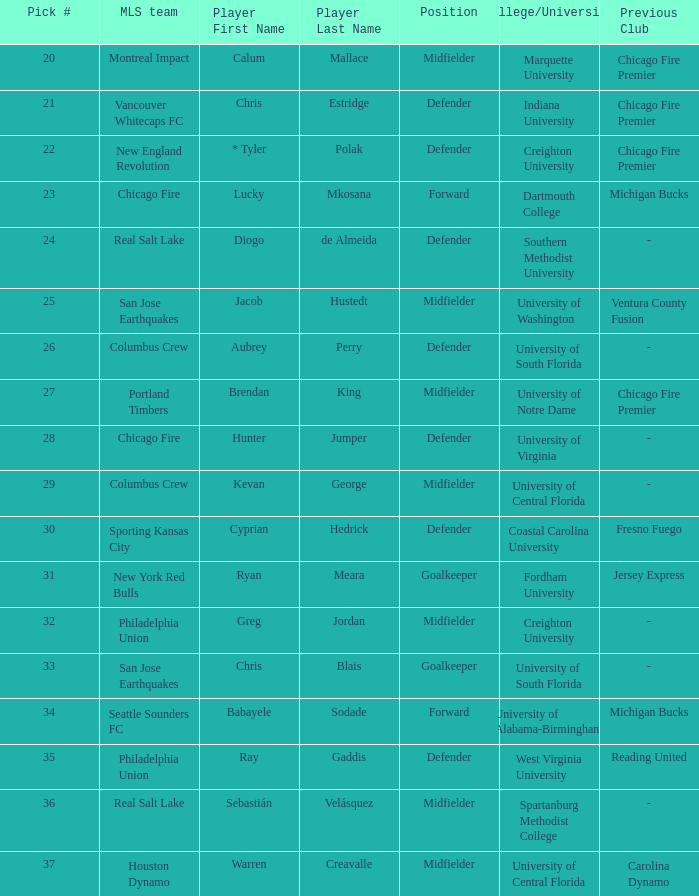What university was Kevan George affiliated with? University of Central Florida. 